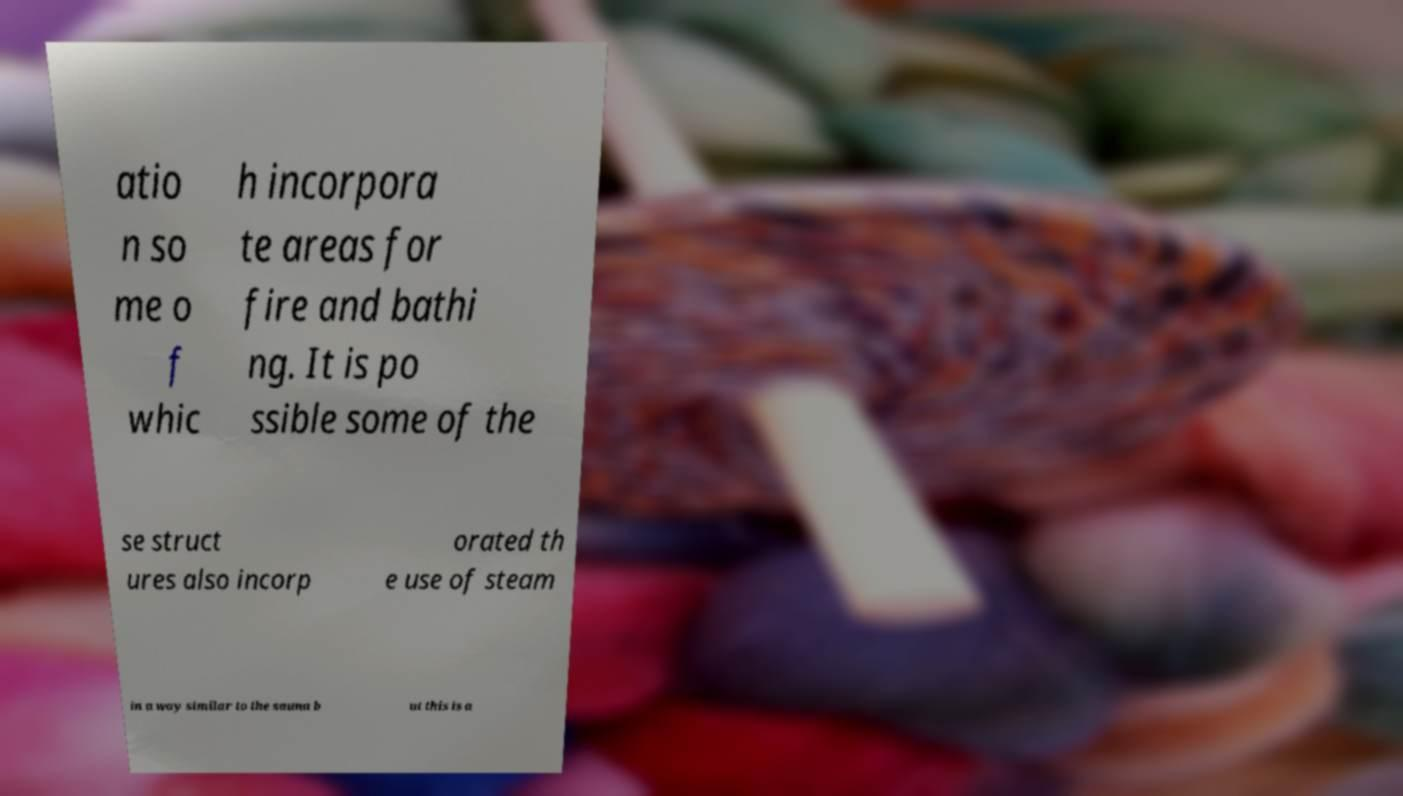There's text embedded in this image that I need extracted. Can you transcribe it verbatim? atio n so me o f whic h incorpora te areas for fire and bathi ng. It is po ssible some of the se struct ures also incorp orated th e use of steam in a way similar to the sauna b ut this is a 